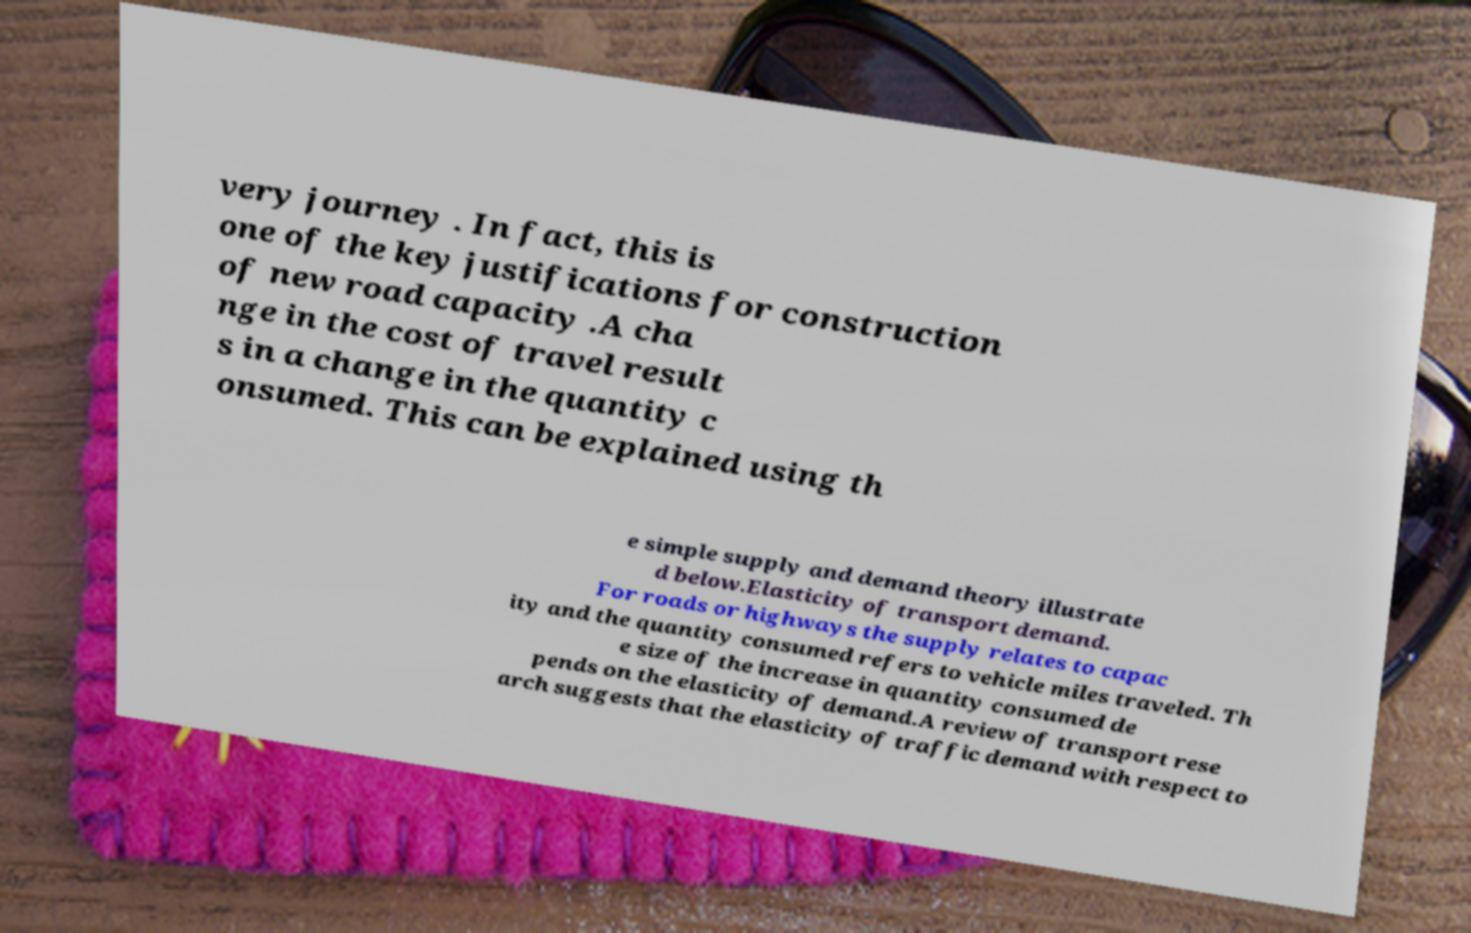I need the written content from this picture converted into text. Can you do that? very journey . In fact, this is one of the key justifications for construction of new road capacity .A cha nge in the cost of travel result s in a change in the quantity c onsumed. This can be explained using th e simple supply and demand theory illustrate d below.Elasticity of transport demand. For roads or highways the supply relates to capac ity and the quantity consumed refers to vehicle miles traveled. Th e size of the increase in quantity consumed de pends on the elasticity of demand.A review of transport rese arch suggests that the elasticity of traffic demand with respect to 